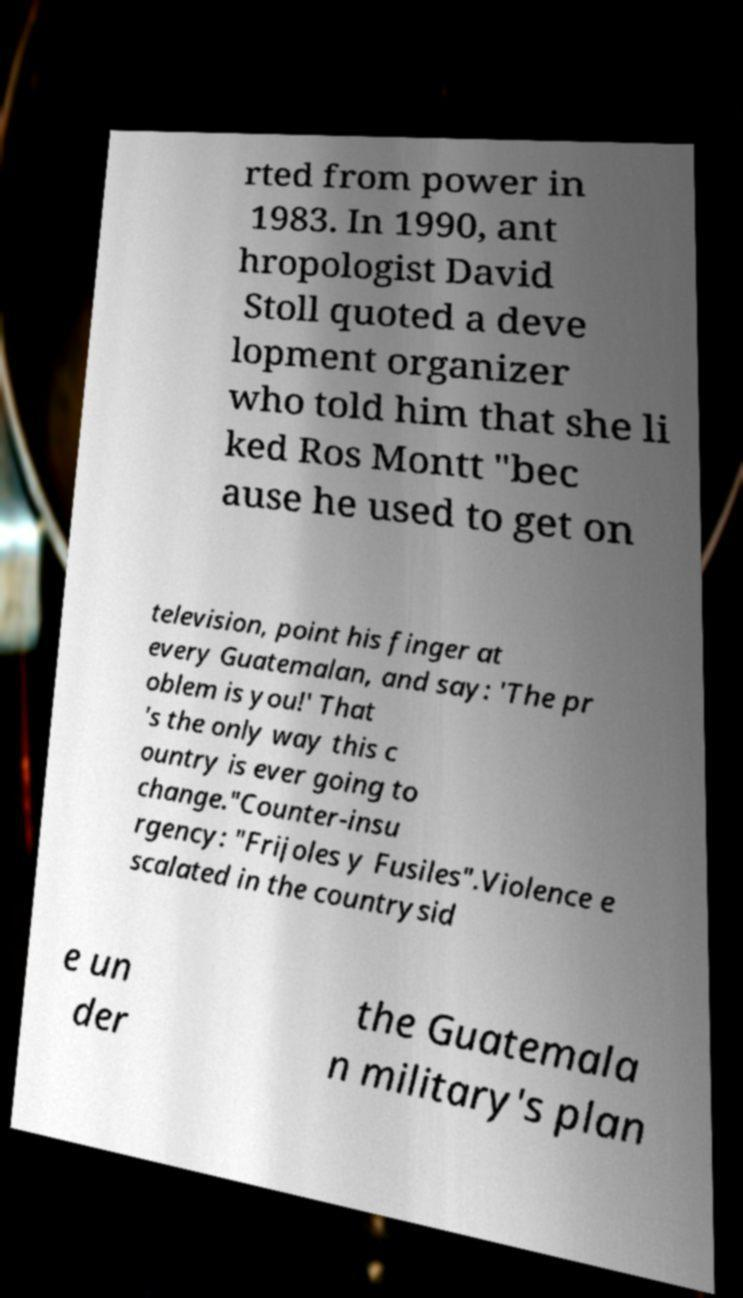For documentation purposes, I need the text within this image transcribed. Could you provide that? rted from power in 1983. In 1990, ant hropologist David Stoll quoted a deve lopment organizer who told him that she li ked Ros Montt "bec ause he used to get on television, point his finger at every Guatemalan, and say: 'The pr oblem is you!' That 's the only way this c ountry is ever going to change."Counter-insu rgency: "Frijoles y Fusiles".Violence e scalated in the countrysid e un der the Guatemala n military's plan 